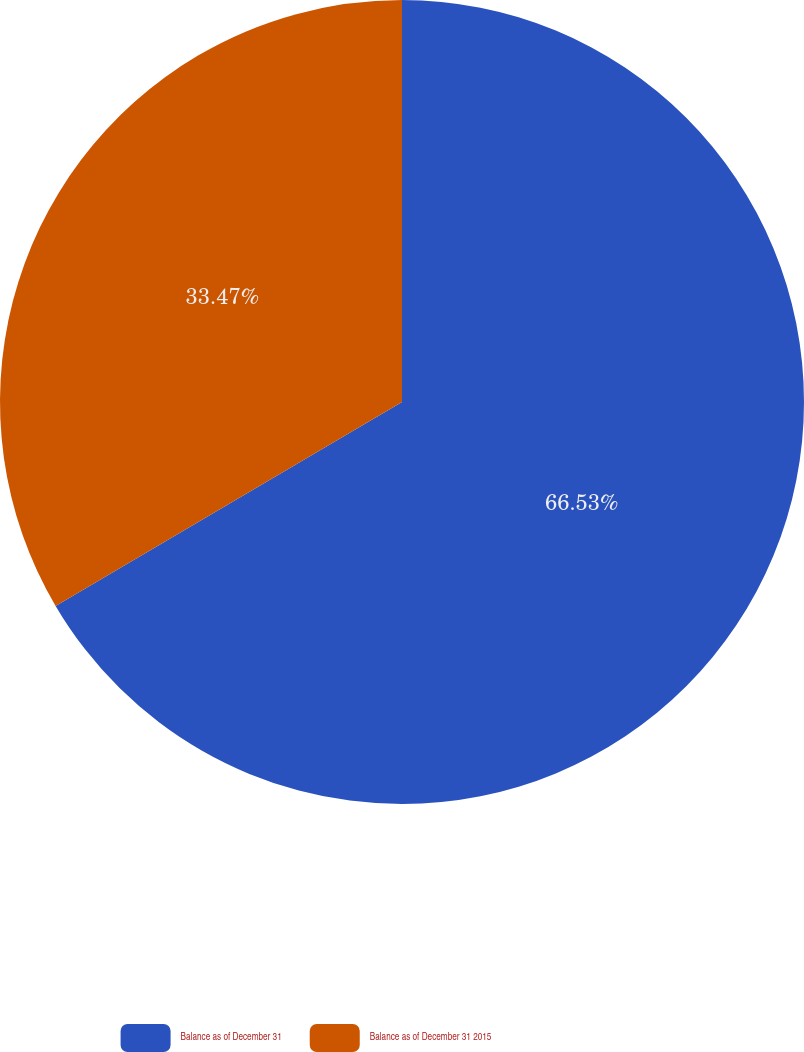<chart> <loc_0><loc_0><loc_500><loc_500><pie_chart><fcel>Balance as of December 31<fcel>Balance as of December 31 2015<nl><fcel>66.53%<fcel>33.47%<nl></chart> 